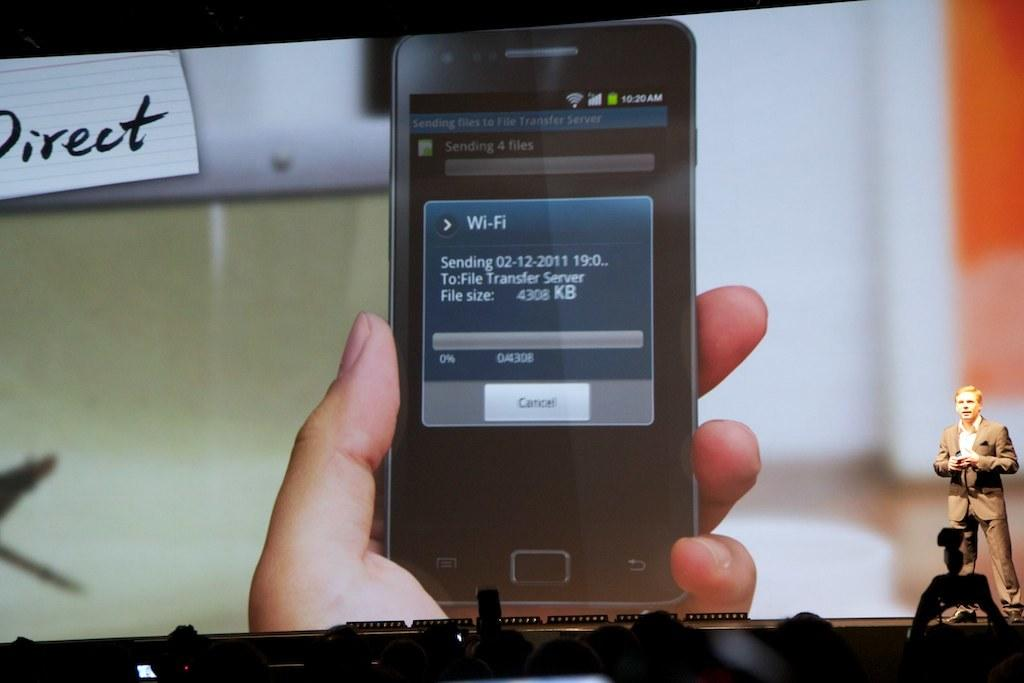What is the man in the image doing? The man is standing on a dais in the image. What is behind the man on the dais? There is a screen behind the man, displaying a mobile phone. Who is present in front of the dais? There is a crowd in front of the dais. What type of lumber is being used to build the dais in the image? There is no mention of lumber or any construction materials in the image. The dais is likely made of a different material, such as wood or metal. 